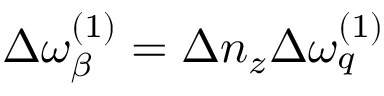<formula> <loc_0><loc_0><loc_500><loc_500>\Delta \omega _ { \beta } ^ { ( 1 ) } = \Delta n _ { z } \Delta \omega _ { q } ^ { ( 1 ) }</formula> 